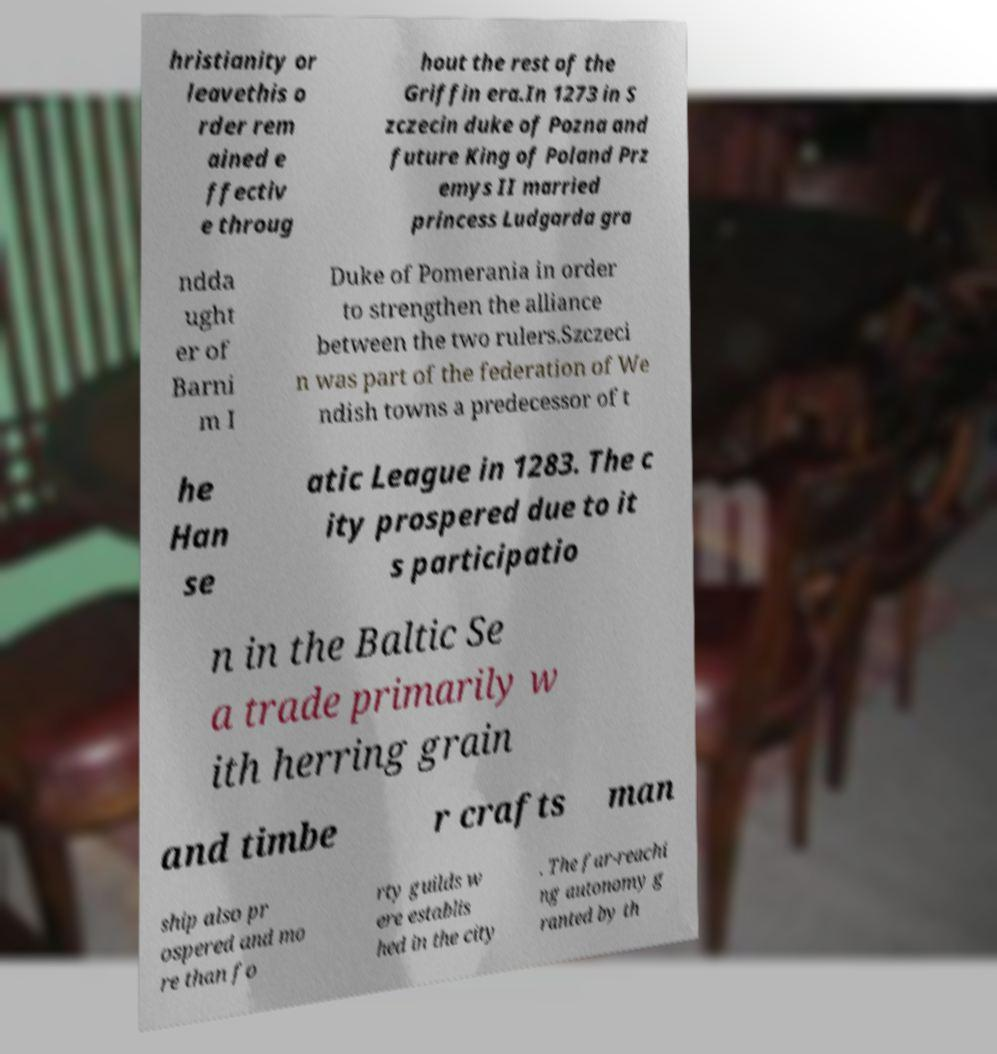Could you extract and type out the text from this image? hristianity or leavethis o rder rem ained e ffectiv e throug hout the rest of the Griffin era.In 1273 in S zczecin duke of Pozna and future King of Poland Prz emys II married princess Ludgarda gra ndda ught er of Barni m I Duke of Pomerania in order to strengthen the alliance between the two rulers.Szczeci n was part of the federation of We ndish towns a predecessor of t he Han se atic League in 1283. The c ity prospered due to it s participatio n in the Baltic Se a trade primarily w ith herring grain and timbe r crafts man ship also pr ospered and mo re than fo rty guilds w ere establis hed in the city . The far-reachi ng autonomy g ranted by th 